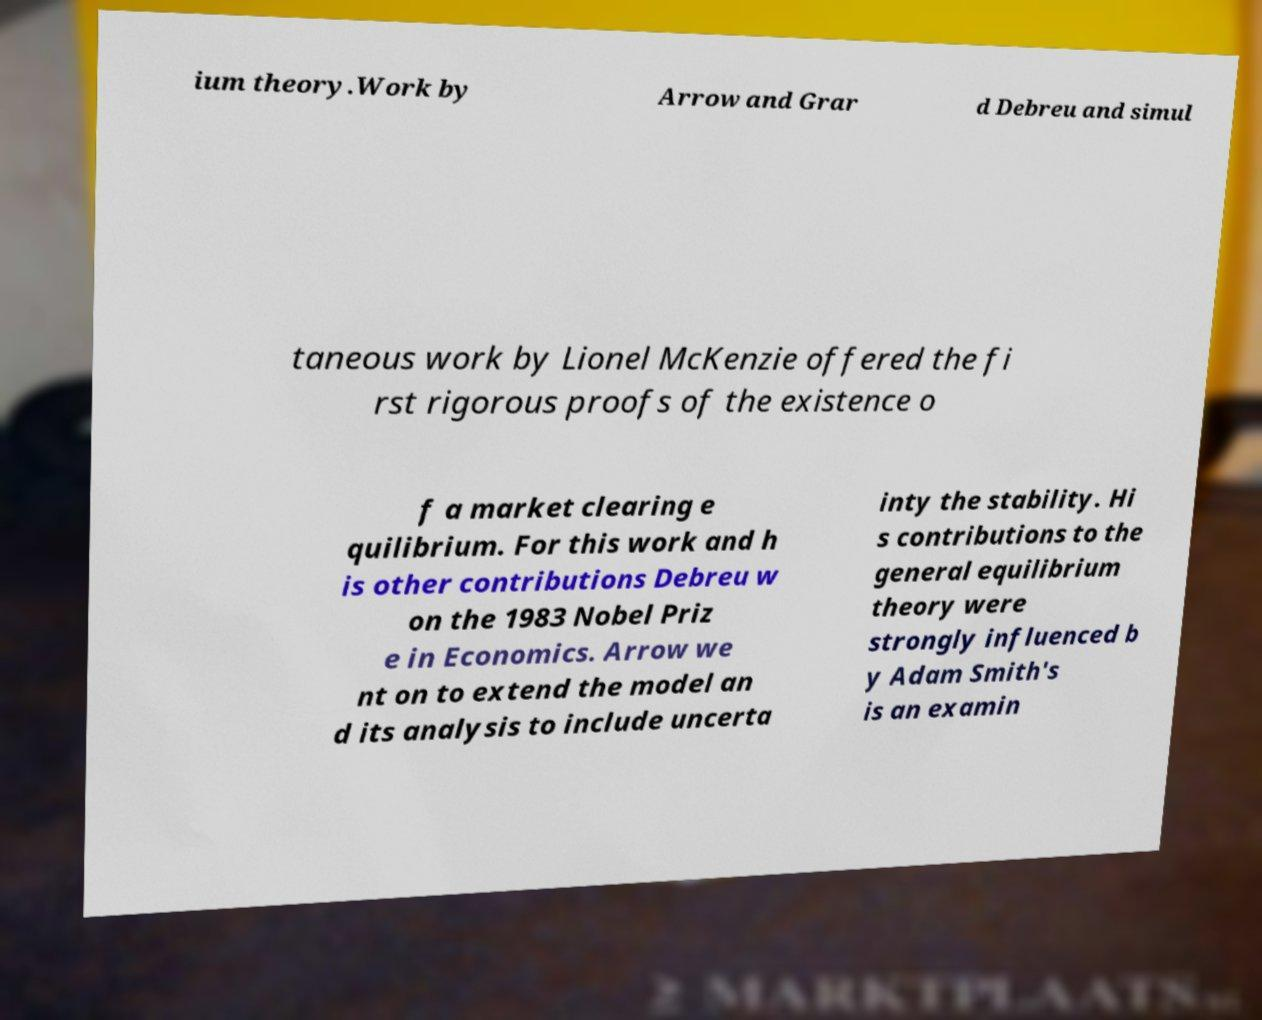Can you read and provide the text displayed in the image?This photo seems to have some interesting text. Can you extract and type it out for me? ium theory.Work by Arrow and Grar d Debreu and simul taneous work by Lionel McKenzie offered the fi rst rigorous proofs of the existence o f a market clearing e quilibrium. For this work and h is other contributions Debreu w on the 1983 Nobel Priz e in Economics. Arrow we nt on to extend the model an d its analysis to include uncerta inty the stability. Hi s contributions to the general equilibrium theory were strongly influenced b y Adam Smith's is an examin 